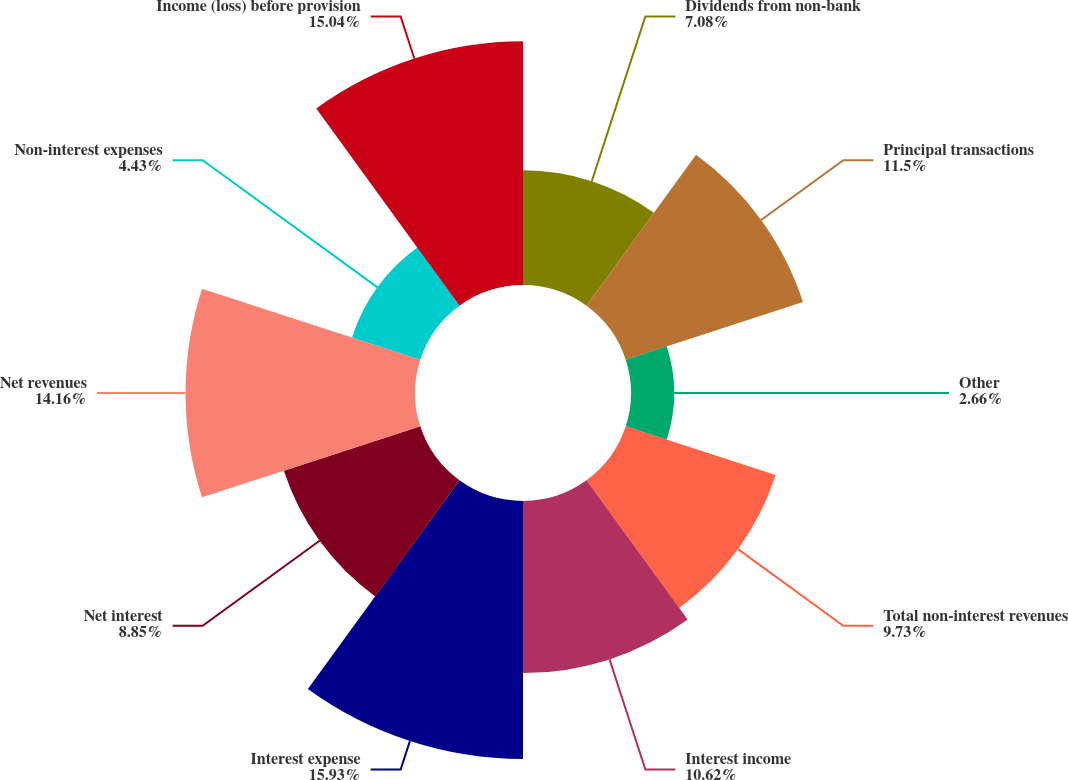<chart> <loc_0><loc_0><loc_500><loc_500><pie_chart><fcel>Dividends from non-bank<fcel>Principal transactions<fcel>Other<fcel>Total non-interest revenues<fcel>Interest income<fcel>Interest expense<fcel>Net interest<fcel>Net revenues<fcel>Non-interest expenses<fcel>Income (loss) before provision<nl><fcel>7.08%<fcel>11.5%<fcel>2.66%<fcel>9.73%<fcel>10.62%<fcel>15.92%<fcel>8.85%<fcel>14.16%<fcel>4.43%<fcel>15.04%<nl></chart> 